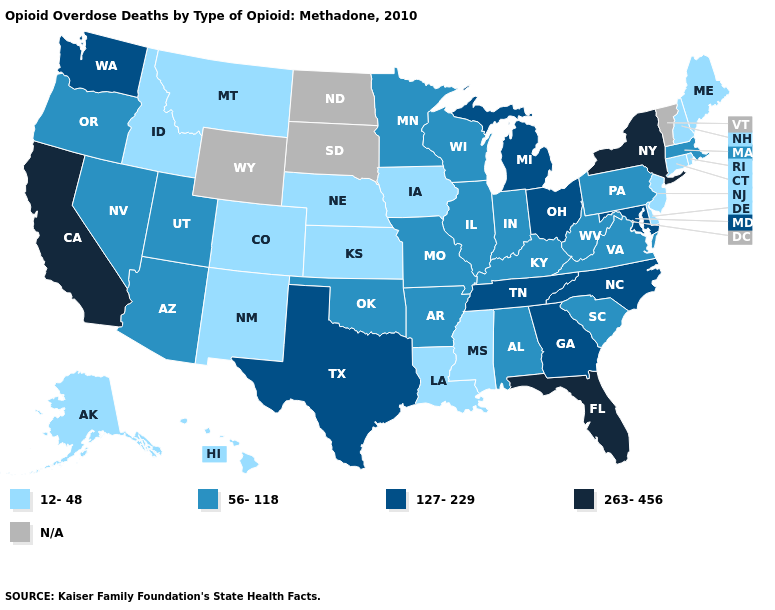Does Hawaii have the lowest value in the USA?
Give a very brief answer. Yes. Name the states that have a value in the range 12-48?
Write a very short answer. Alaska, Colorado, Connecticut, Delaware, Hawaii, Idaho, Iowa, Kansas, Louisiana, Maine, Mississippi, Montana, Nebraska, New Hampshire, New Jersey, New Mexico, Rhode Island. What is the highest value in the USA?
Write a very short answer. 263-456. Among the states that border Oregon , which have the lowest value?
Quick response, please. Idaho. What is the value of New Jersey?
Answer briefly. 12-48. Does the map have missing data?
Keep it brief. Yes. Among the states that border Indiana , which have the highest value?
Concise answer only. Michigan, Ohio. Does the first symbol in the legend represent the smallest category?
Write a very short answer. Yes. What is the highest value in the USA?
Short answer required. 263-456. Name the states that have a value in the range N/A?
Be succinct. North Dakota, South Dakota, Vermont, Wyoming. What is the value of South Carolina?
Short answer required. 56-118. Name the states that have a value in the range 263-456?
Short answer required. California, Florida, New York. What is the value of Utah?
Be succinct. 56-118. What is the value of Florida?
Answer briefly. 263-456. Does Nebraska have the highest value in the USA?
Quick response, please. No. 